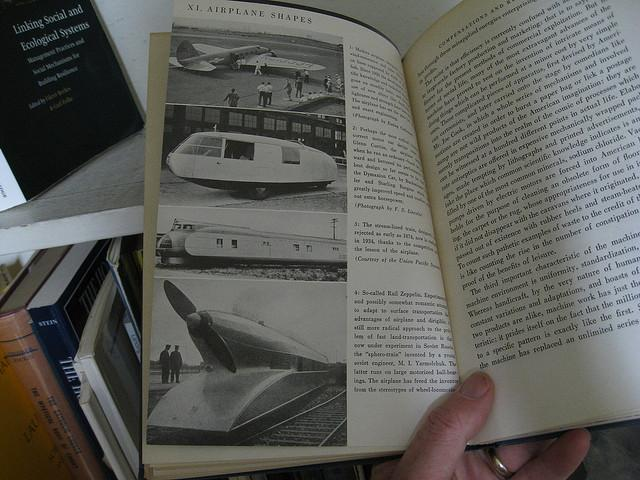What kind of object is to the front of this strange train? Please explain your reasoning. propeller. The object is a propeller. 